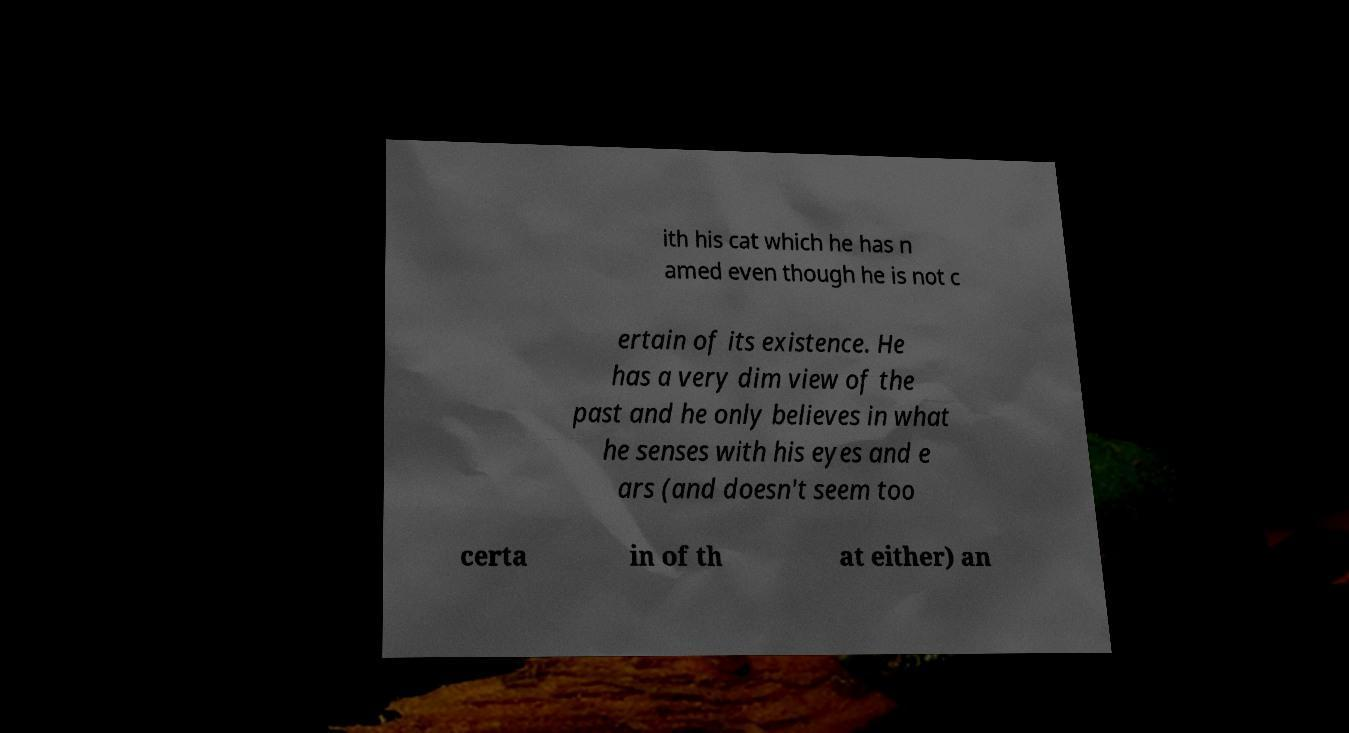Could you extract and type out the text from this image? ith his cat which he has n amed even though he is not c ertain of its existence. He has a very dim view of the past and he only believes in what he senses with his eyes and e ars (and doesn't seem too certa in of th at either) an 